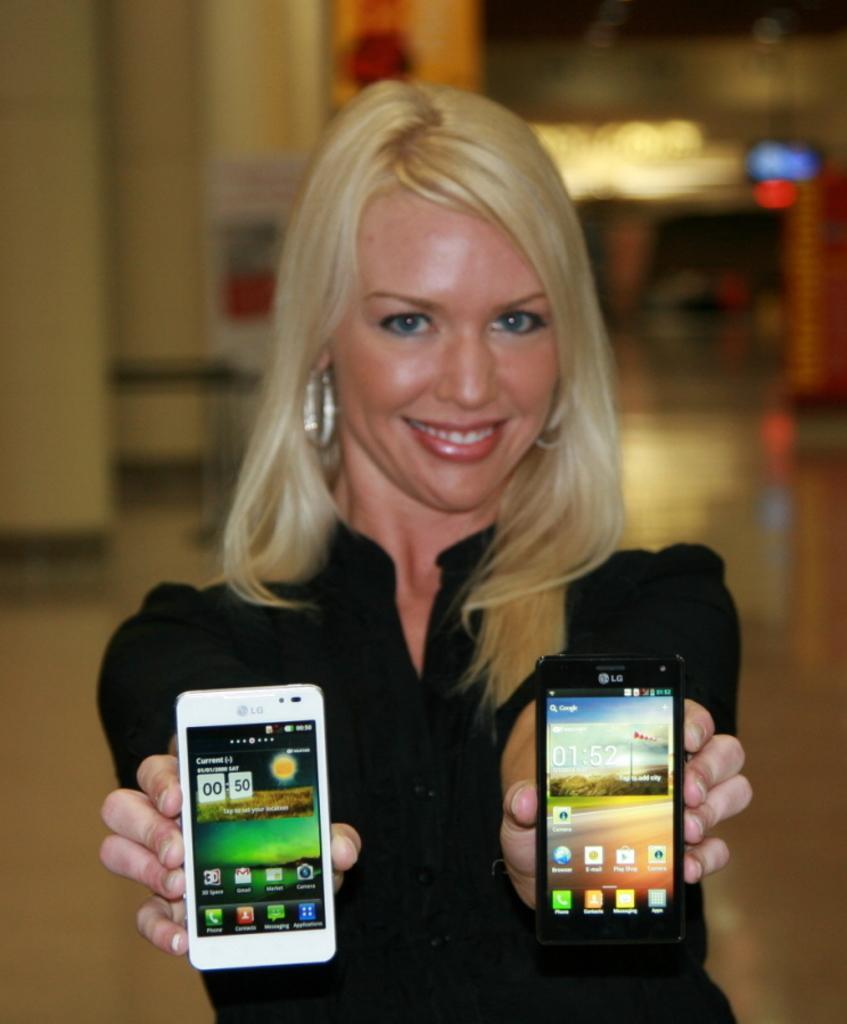Describe this image in one or two sentences. In the image there is a woman who is holding two mobiles in her two hands. In background we can see a wall. 